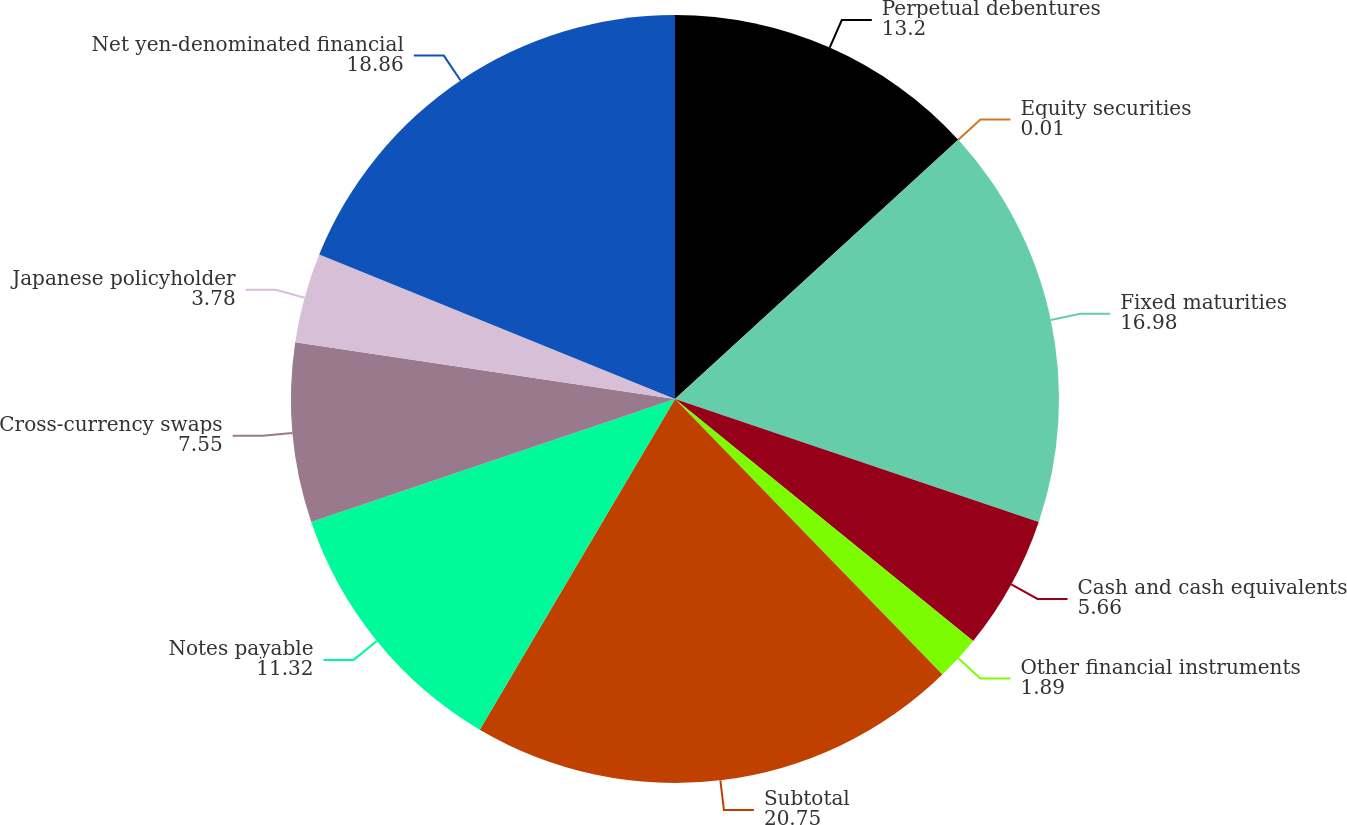Convert chart. <chart><loc_0><loc_0><loc_500><loc_500><pie_chart><fcel>Perpetual debentures<fcel>Equity securities<fcel>Fixed maturities<fcel>Cash and cash equivalents<fcel>Other financial instruments<fcel>Subtotal<fcel>Notes payable<fcel>Cross-currency swaps<fcel>Japanese policyholder<fcel>Net yen-denominated financial<nl><fcel>13.2%<fcel>0.01%<fcel>16.98%<fcel>5.66%<fcel>1.89%<fcel>20.75%<fcel>11.32%<fcel>7.55%<fcel>3.78%<fcel>18.86%<nl></chart> 